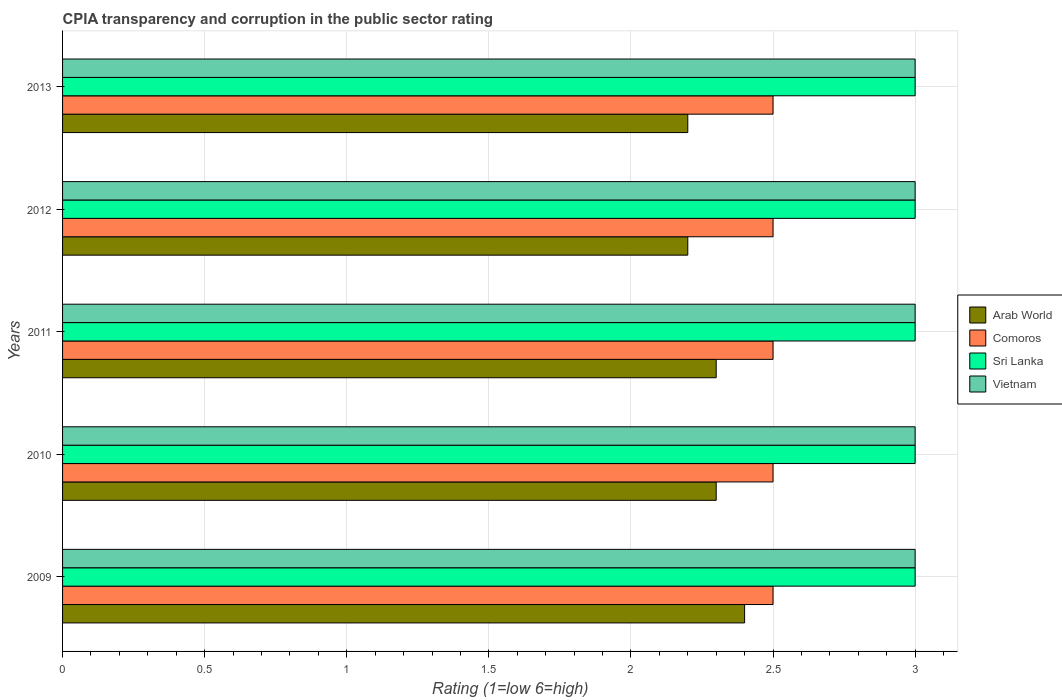Are the number of bars on each tick of the Y-axis equal?
Give a very brief answer. Yes. How many bars are there on the 1st tick from the bottom?
Give a very brief answer. 4. In how many cases, is the number of bars for a given year not equal to the number of legend labels?
Give a very brief answer. 0. Across all years, what is the minimum CPIA rating in Sri Lanka?
Your response must be concise. 3. In which year was the CPIA rating in Arab World minimum?
Your answer should be compact. 2012. What is the total CPIA rating in Vietnam in the graph?
Your response must be concise. 15. What is the difference between the CPIA rating in Comoros in 2009 and that in 2012?
Your response must be concise. 0. What is the difference between the CPIA rating in Comoros in 2009 and the CPIA rating in Arab World in 2012?
Ensure brevity in your answer.  0.3. In the year 2009, what is the difference between the CPIA rating in Sri Lanka and CPIA rating in Arab World?
Keep it short and to the point. 0.6. In how many years, is the CPIA rating in Comoros greater than 2.8 ?
Give a very brief answer. 0. What is the ratio of the CPIA rating in Arab World in 2009 to that in 2012?
Your answer should be very brief. 1.09. Is the CPIA rating in Comoros in 2011 less than that in 2012?
Your answer should be compact. No. What is the difference between the highest and the second highest CPIA rating in Arab World?
Your answer should be very brief. 0.1. What does the 2nd bar from the top in 2009 represents?
Your answer should be compact. Sri Lanka. What does the 3rd bar from the bottom in 2012 represents?
Your answer should be very brief. Sri Lanka. Are the values on the major ticks of X-axis written in scientific E-notation?
Offer a terse response. No. Does the graph contain any zero values?
Give a very brief answer. No. Does the graph contain grids?
Offer a terse response. Yes. How many legend labels are there?
Keep it short and to the point. 4. What is the title of the graph?
Ensure brevity in your answer.  CPIA transparency and corruption in the public sector rating. Does "New Zealand" appear as one of the legend labels in the graph?
Offer a terse response. No. What is the label or title of the X-axis?
Ensure brevity in your answer.  Rating (1=low 6=high). What is the Rating (1=low 6=high) in Arab World in 2009?
Provide a succinct answer. 2.4. What is the Rating (1=low 6=high) of Comoros in 2009?
Offer a terse response. 2.5. What is the Rating (1=low 6=high) of Vietnam in 2009?
Ensure brevity in your answer.  3. What is the Rating (1=low 6=high) of Arab World in 2010?
Provide a succinct answer. 2.3. What is the Rating (1=low 6=high) of Sri Lanka in 2010?
Ensure brevity in your answer.  3. What is the Rating (1=low 6=high) of Arab World in 2011?
Your answer should be very brief. 2.3. What is the Rating (1=low 6=high) in Comoros in 2011?
Keep it short and to the point. 2.5. What is the Rating (1=low 6=high) in Sri Lanka in 2011?
Your response must be concise. 3. What is the Rating (1=low 6=high) of Arab World in 2012?
Provide a short and direct response. 2.2. What is the Rating (1=low 6=high) of Comoros in 2012?
Your answer should be compact. 2.5. What is the Rating (1=low 6=high) in Sri Lanka in 2012?
Your response must be concise. 3. What is the Rating (1=low 6=high) in Vietnam in 2012?
Your response must be concise. 3. Across all years, what is the minimum Rating (1=low 6=high) in Arab World?
Provide a short and direct response. 2.2. Across all years, what is the minimum Rating (1=low 6=high) in Comoros?
Make the answer very short. 2.5. What is the total Rating (1=low 6=high) of Arab World in the graph?
Give a very brief answer. 11.4. What is the total Rating (1=low 6=high) of Comoros in the graph?
Provide a short and direct response. 12.5. What is the total Rating (1=low 6=high) of Sri Lanka in the graph?
Your answer should be compact. 15. What is the difference between the Rating (1=low 6=high) in Arab World in 2009 and that in 2010?
Provide a short and direct response. 0.1. What is the difference between the Rating (1=low 6=high) in Sri Lanka in 2009 and that in 2010?
Offer a terse response. 0. What is the difference between the Rating (1=low 6=high) in Comoros in 2009 and that in 2011?
Your answer should be very brief. 0. What is the difference between the Rating (1=low 6=high) of Vietnam in 2009 and that in 2011?
Your answer should be compact. 0. What is the difference between the Rating (1=low 6=high) of Arab World in 2009 and that in 2012?
Offer a very short reply. 0.2. What is the difference between the Rating (1=low 6=high) in Sri Lanka in 2009 and that in 2012?
Make the answer very short. 0. What is the difference between the Rating (1=low 6=high) in Comoros in 2009 and that in 2013?
Your response must be concise. 0. What is the difference between the Rating (1=low 6=high) of Vietnam in 2009 and that in 2013?
Offer a very short reply. 0. What is the difference between the Rating (1=low 6=high) in Arab World in 2010 and that in 2011?
Your answer should be very brief. 0. What is the difference between the Rating (1=low 6=high) in Comoros in 2010 and that in 2011?
Your answer should be very brief. 0. What is the difference between the Rating (1=low 6=high) in Vietnam in 2010 and that in 2011?
Give a very brief answer. 0. What is the difference between the Rating (1=low 6=high) of Comoros in 2010 and that in 2012?
Offer a terse response. 0. What is the difference between the Rating (1=low 6=high) of Sri Lanka in 2010 and that in 2012?
Provide a short and direct response. 0. What is the difference between the Rating (1=low 6=high) of Vietnam in 2010 and that in 2012?
Ensure brevity in your answer.  0. What is the difference between the Rating (1=low 6=high) in Arab World in 2010 and that in 2013?
Provide a short and direct response. 0.1. What is the difference between the Rating (1=low 6=high) of Comoros in 2010 and that in 2013?
Offer a very short reply. 0. What is the difference between the Rating (1=low 6=high) in Comoros in 2011 and that in 2012?
Offer a terse response. 0. What is the difference between the Rating (1=low 6=high) in Vietnam in 2011 and that in 2012?
Offer a terse response. 0. What is the difference between the Rating (1=low 6=high) in Arab World in 2012 and that in 2013?
Provide a succinct answer. 0. What is the difference between the Rating (1=low 6=high) in Comoros in 2012 and that in 2013?
Your answer should be compact. 0. What is the difference between the Rating (1=low 6=high) of Vietnam in 2012 and that in 2013?
Your answer should be very brief. 0. What is the difference between the Rating (1=low 6=high) of Comoros in 2009 and the Rating (1=low 6=high) of Sri Lanka in 2010?
Your answer should be very brief. -0.5. What is the difference between the Rating (1=low 6=high) in Comoros in 2009 and the Rating (1=low 6=high) in Vietnam in 2010?
Ensure brevity in your answer.  -0.5. What is the difference between the Rating (1=low 6=high) in Arab World in 2009 and the Rating (1=low 6=high) in Sri Lanka in 2011?
Give a very brief answer. -0.6. What is the difference between the Rating (1=low 6=high) in Arab World in 2009 and the Rating (1=low 6=high) in Vietnam in 2011?
Offer a terse response. -0.6. What is the difference between the Rating (1=low 6=high) in Comoros in 2009 and the Rating (1=low 6=high) in Sri Lanka in 2011?
Ensure brevity in your answer.  -0.5. What is the difference between the Rating (1=low 6=high) of Arab World in 2009 and the Rating (1=low 6=high) of Comoros in 2012?
Give a very brief answer. -0.1. What is the difference between the Rating (1=low 6=high) of Arab World in 2009 and the Rating (1=low 6=high) of Sri Lanka in 2012?
Your answer should be compact. -0.6. What is the difference between the Rating (1=low 6=high) of Comoros in 2009 and the Rating (1=low 6=high) of Sri Lanka in 2012?
Offer a very short reply. -0.5. What is the difference between the Rating (1=low 6=high) of Sri Lanka in 2009 and the Rating (1=low 6=high) of Vietnam in 2012?
Provide a short and direct response. 0. What is the difference between the Rating (1=low 6=high) in Comoros in 2009 and the Rating (1=low 6=high) in Vietnam in 2013?
Your answer should be very brief. -0.5. What is the difference between the Rating (1=low 6=high) in Arab World in 2010 and the Rating (1=low 6=high) in Comoros in 2011?
Your answer should be very brief. -0.2. What is the difference between the Rating (1=low 6=high) in Arab World in 2010 and the Rating (1=low 6=high) in Vietnam in 2011?
Your response must be concise. -0.7. What is the difference between the Rating (1=low 6=high) in Comoros in 2010 and the Rating (1=low 6=high) in Sri Lanka in 2011?
Make the answer very short. -0.5. What is the difference between the Rating (1=low 6=high) of Comoros in 2010 and the Rating (1=low 6=high) of Vietnam in 2011?
Your answer should be very brief. -0.5. What is the difference between the Rating (1=low 6=high) of Sri Lanka in 2010 and the Rating (1=low 6=high) of Vietnam in 2011?
Ensure brevity in your answer.  0. What is the difference between the Rating (1=low 6=high) in Arab World in 2010 and the Rating (1=low 6=high) in Comoros in 2012?
Your answer should be compact. -0.2. What is the difference between the Rating (1=low 6=high) of Arab World in 2010 and the Rating (1=low 6=high) of Sri Lanka in 2012?
Offer a terse response. -0.7. What is the difference between the Rating (1=low 6=high) in Arab World in 2010 and the Rating (1=low 6=high) in Vietnam in 2012?
Make the answer very short. -0.7. What is the difference between the Rating (1=low 6=high) in Comoros in 2010 and the Rating (1=low 6=high) in Sri Lanka in 2012?
Your answer should be compact. -0.5. What is the difference between the Rating (1=low 6=high) in Comoros in 2010 and the Rating (1=low 6=high) in Vietnam in 2012?
Ensure brevity in your answer.  -0.5. What is the difference between the Rating (1=low 6=high) of Sri Lanka in 2010 and the Rating (1=low 6=high) of Vietnam in 2012?
Your answer should be compact. 0. What is the difference between the Rating (1=low 6=high) in Arab World in 2010 and the Rating (1=low 6=high) in Sri Lanka in 2013?
Offer a terse response. -0.7. What is the difference between the Rating (1=low 6=high) of Arab World in 2010 and the Rating (1=low 6=high) of Vietnam in 2013?
Provide a short and direct response. -0.7. What is the difference between the Rating (1=low 6=high) in Sri Lanka in 2010 and the Rating (1=low 6=high) in Vietnam in 2013?
Ensure brevity in your answer.  0. What is the difference between the Rating (1=low 6=high) of Arab World in 2011 and the Rating (1=low 6=high) of Comoros in 2012?
Provide a short and direct response. -0.2. What is the difference between the Rating (1=low 6=high) in Arab World in 2011 and the Rating (1=low 6=high) in Sri Lanka in 2012?
Your answer should be compact. -0.7. What is the difference between the Rating (1=low 6=high) of Arab World in 2011 and the Rating (1=low 6=high) of Vietnam in 2012?
Your answer should be compact. -0.7. What is the difference between the Rating (1=low 6=high) in Comoros in 2011 and the Rating (1=low 6=high) in Sri Lanka in 2012?
Your answer should be compact. -0.5. What is the difference between the Rating (1=low 6=high) in Comoros in 2011 and the Rating (1=low 6=high) in Vietnam in 2012?
Ensure brevity in your answer.  -0.5. What is the difference between the Rating (1=low 6=high) in Sri Lanka in 2011 and the Rating (1=low 6=high) in Vietnam in 2012?
Give a very brief answer. 0. What is the difference between the Rating (1=low 6=high) of Comoros in 2011 and the Rating (1=low 6=high) of Sri Lanka in 2013?
Offer a terse response. -0.5. What is the difference between the Rating (1=low 6=high) of Sri Lanka in 2011 and the Rating (1=low 6=high) of Vietnam in 2013?
Keep it short and to the point. 0. What is the difference between the Rating (1=low 6=high) of Arab World in 2012 and the Rating (1=low 6=high) of Vietnam in 2013?
Give a very brief answer. -0.8. What is the difference between the Rating (1=low 6=high) of Comoros in 2012 and the Rating (1=low 6=high) of Vietnam in 2013?
Give a very brief answer. -0.5. What is the difference between the Rating (1=low 6=high) in Sri Lanka in 2012 and the Rating (1=low 6=high) in Vietnam in 2013?
Your answer should be very brief. 0. What is the average Rating (1=low 6=high) in Arab World per year?
Keep it short and to the point. 2.28. In the year 2009, what is the difference between the Rating (1=low 6=high) in Arab World and Rating (1=low 6=high) in Comoros?
Keep it short and to the point. -0.1. In the year 2009, what is the difference between the Rating (1=low 6=high) in Arab World and Rating (1=low 6=high) in Sri Lanka?
Your response must be concise. -0.6. In the year 2009, what is the difference between the Rating (1=low 6=high) in Comoros and Rating (1=low 6=high) in Vietnam?
Provide a short and direct response. -0.5. In the year 2010, what is the difference between the Rating (1=low 6=high) of Arab World and Rating (1=low 6=high) of Comoros?
Your answer should be compact. -0.2. In the year 2010, what is the difference between the Rating (1=low 6=high) in Arab World and Rating (1=low 6=high) in Sri Lanka?
Offer a terse response. -0.7. In the year 2010, what is the difference between the Rating (1=low 6=high) in Comoros and Rating (1=low 6=high) in Vietnam?
Ensure brevity in your answer.  -0.5. In the year 2010, what is the difference between the Rating (1=low 6=high) in Sri Lanka and Rating (1=low 6=high) in Vietnam?
Your answer should be very brief. 0. In the year 2011, what is the difference between the Rating (1=low 6=high) of Arab World and Rating (1=low 6=high) of Comoros?
Your answer should be compact. -0.2. In the year 2011, what is the difference between the Rating (1=low 6=high) of Arab World and Rating (1=low 6=high) of Vietnam?
Your answer should be compact. -0.7. In the year 2011, what is the difference between the Rating (1=low 6=high) of Comoros and Rating (1=low 6=high) of Sri Lanka?
Your answer should be very brief. -0.5. In the year 2011, what is the difference between the Rating (1=low 6=high) of Comoros and Rating (1=low 6=high) of Vietnam?
Provide a short and direct response. -0.5. In the year 2011, what is the difference between the Rating (1=low 6=high) of Sri Lanka and Rating (1=low 6=high) of Vietnam?
Give a very brief answer. 0. In the year 2012, what is the difference between the Rating (1=low 6=high) of Arab World and Rating (1=low 6=high) of Comoros?
Ensure brevity in your answer.  -0.3. In the year 2012, what is the difference between the Rating (1=low 6=high) of Arab World and Rating (1=low 6=high) of Sri Lanka?
Give a very brief answer. -0.8. In the year 2012, what is the difference between the Rating (1=low 6=high) in Sri Lanka and Rating (1=low 6=high) in Vietnam?
Your response must be concise. 0. In the year 2013, what is the difference between the Rating (1=low 6=high) of Arab World and Rating (1=low 6=high) of Sri Lanka?
Give a very brief answer. -0.8. In the year 2013, what is the difference between the Rating (1=low 6=high) in Comoros and Rating (1=low 6=high) in Sri Lanka?
Make the answer very short. -0.5. In the year 2013, what is the difference between the Rating (1=low 6=high) in Comoros and Rating (1=low 6=high) in Vietnam?
Make the answer very short. -0.5. In the year 2013, what is the difference between the Rating (1=low 6=high) of Sri Lanka and Rating (1=low 6=high) of Vietnam?
Offer a very short reply. 0. What is the ratio of the Rating (1=low 6=high) of Arab World in 2009 to that in 2010?
Ensure brevity in your answer.  1.04. What is the ratio of the Rating (1=low 6=high) in Comoros in 2009 to that in 2010?
Your answer should be compact. 1. What is the ratio of the Rating (1=low 6=high) of Sri Lanka in 2009 to that in 2010?
Keep it short and to the point. 1. What is the ratio of the Rating (1=low 6=high) of Vietnam in 2009 to that in 2010?
Your response must be concise. 1. What is the ratio of the Rating (1=low 6=high) in Arab World in 2009 to that in 2011?
Provide a short and direct response. 1.04. What is the ratio of the Rating (1=low 6=high) of Comoros in 2009 to that in 2011?
Keep it short and to the point. 1. What is the ratio of the Rating (1=low 6=high) of Comoros in 2009 to that in 2012?
Your response must be concise. 1. What is the ratio of the Rating (1=low 6=high) in Vietnam in 2009 to that in 2012?
Your answer should be very brief. 1. What is the ratio of the Rating (1=low 6=high) of Sri Lanka in 2009 to that in 2013?
Make the answer very short. 1. What is the ratio of the Rating (1=low 6=high) of Vietnam in 2009 to that in 2013?
Offer a very short reply. 1. What is the ratio of the Rating (1=low 6=high) of Arab World in 2010 to that in 2011?
Provide a short and direct response. 1. What is the ratio of the Rating (1=low 6=high) of Vietnam in 2010 to that in 2011?
Ensure brevity in your answer.  1. What is the ratio of the Rating (1=low 6=high) of Arab World in 2010 to that in 2012?
Offer a terse response. 1.05. What is the ratio of the Rating (1=low 6=high) in Comoros in 2010 to that in 2012?
Your answer should be very brief. 1. What is the ratio of the Rating (1=low 6=high) of Sri Lanka in 2010 to that in 2012?
Make the answer very short. 1. What is the ratio of the Rating (1=low 6=high) of Vietnam in 2010 to that in 2012?
Offer a terse response. 1. What is the ratio of the Rating (1=low 6=high) of Arab World in 2010 to that in 2013?
Provide a succinct answer. 1.05. What is the ratio of the Rating (1=low 6=high) in Comoros in 2010 to that in 2013?
Provide a short and direct response. 1. What is the ratio of the Rating (1=low 6=high) in Vietnam in 2010 to that in 2013?
Provide a short and direct response. 1. What is the ratio of the Rating (1=low 6=high) of Arab World in 2011 to that in 2012?
Provide a short and direct response. 1.05. What is the ratio of the Rating (1=low 6=high) of Comoros in 2011 to that in 2012?
Make the answer very short. 1. What is the ratio of the Rating (1=low 6=high) in Vietnam in 2011 to that in 2012?
Give a very brief answer. 1. What is the ratio of the Rating (1=low 6=high) in Arab World in 2011 to that in 2013?
Offer a very short reply. 1.05. What is the ratio of the Rating (1=low 6=high) of Comoros in 2011 to that in 2013?
Offer a terse response. 1. What is the ratio of the Rating (1=low 6=high) of Sri Lanka in 2011 to that in 2013?
Offer a terse response. 1. What is the ratio of the Rating (1=low 6=high) of Vietnam in 2011 to that in 2013?
Ensure brevity in your answer.  1. What is the ratio of the Rating (1=low 6=high) in Comoros in 2012 to that in 2013?
Provide a short and direct response. 1. What is the difference between the highest and the second highest Rating (1=low 6=high) of Arab World?
Provide a succinct answer. 0.1. What is the difference between the highest and the second highest Rating (1=low 6=high) in Comoros?
Your response must be concise. 0. What is the difference between the highest and the lowest Rating (1=low 6=high) in Arab World?
Offer a very short reply. 0.2. What is the difference between the highest and the lowest Rating (1=low 6=high) of Comoros?
Make the answer very short. 0. What is the difference between the highest and the lowest Rating (1=low 6=high) in Sri Lanka?
Keep it short and to the point. 0. 